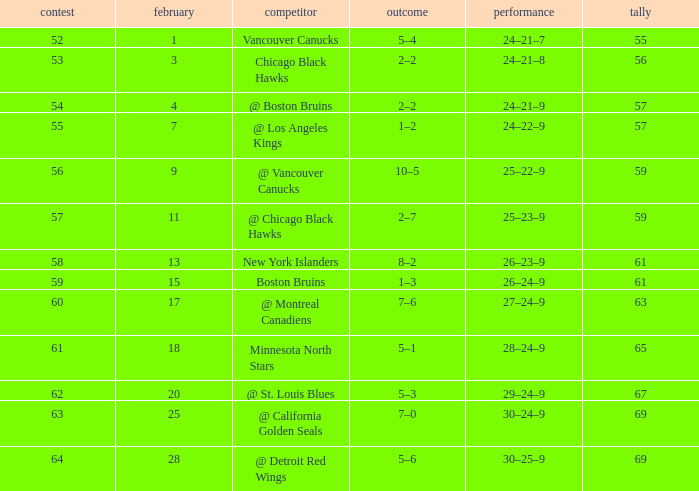How many february games had a record of 29–24–9? 20.0. 